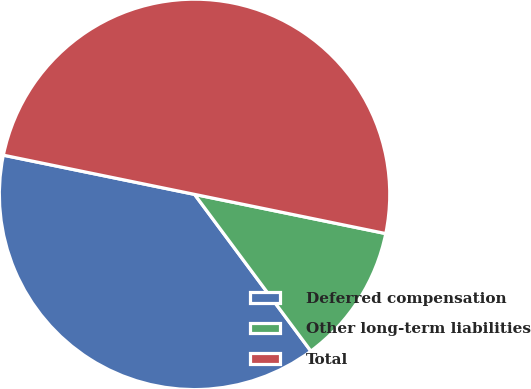<chart> <loc_0><loc_0><loc_500><loc_500><pie_chart><fcel>Deferred compensation<fcel>Other long-term liabilities<fcel>Total<nl><fcel>38.38%<fcel>11.62%<fcel>50.0%<nl></chart> 